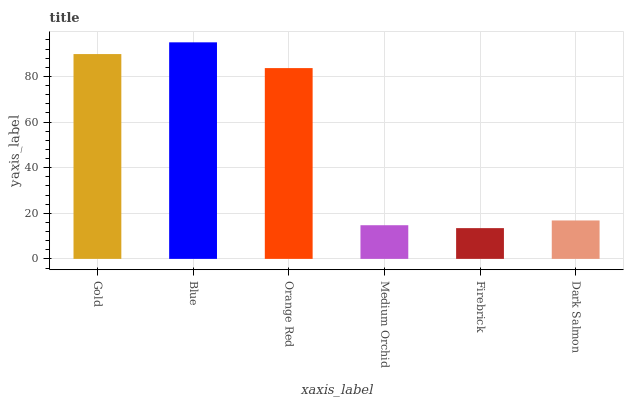Is Firebrick the minimum?
Answer yes or no. Yes. Is Blue the maximum?
Answer yes or no. Yes. Is Orange Red the minimum?
Answer yes or no. No. Is Orange Red the maximum?
Answer yes or no. No. Is Blue greater than Orange Red?
Answer yes or no. Yes. Is Orange Red less than Blue?
Answer yes or no. Yes. Is Orange Red greater than Blue?
Answer yes or no. No. Is Blue less than Orange Red?
Answer yes or no. No. Is Orange Red the high median?
Answer yes or no. Yes. Is Dark Salmon the low median?
Answer yes or no. Yes. Is Gold the high median?
Answer yes or no. No. Is Blue the low median?
Answer yes or no. No. 